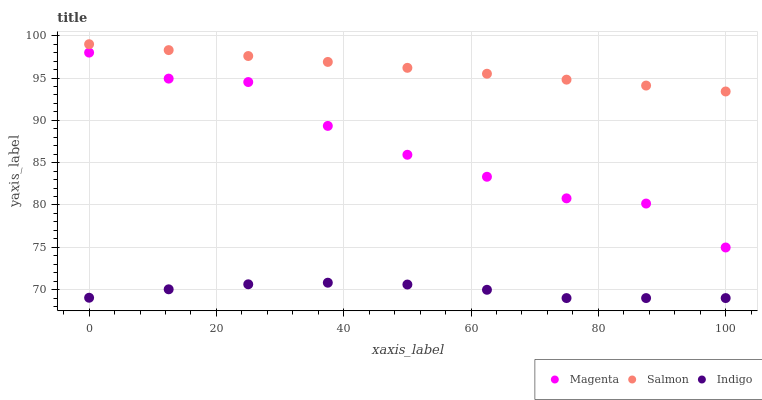Does Indigo have the minimum area under the curve?
Answer yes or no. Yes. Does Salmon have the maximum area under the curve?
Answer yes or no. Yes. Does Magenta have the minimum area under the curve?
Answer yes or no. No. Does Magenta have the maximum area under the curve?
Answer yes or no. No. Is Salmon the smoothest?
Answer yes or no. Yes. Is Magenta the roughest?
Answer yes or no. Yes. Is Magenta the smoothest?
Answer yes or no. No. Is Salmon the roughest?
Answer yes or no. No. Does Indigo have the lowest value?
Answer yes or no. Yes. Does Magenta have the lowest value?
Answer yes or no. No. Does Salmon have the highest value?
Answer yes or no. Yes. Does Magenta have the highest value?
Answer yes or no. No. Is Indigo less than Magenta?
Answer yes or no. Yes. Is Salmon greater than Indigo?
Answer yes or no. Yes. Does Indigo intersect Magenta?
Answer yes or no. No. 